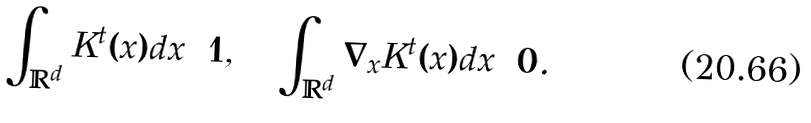Convert formula to latex. <formula><loc_0><loc_0><loc_500><loc_500>\int _ { \mathbb { R } ^ { d } } K ^ { t } ( x ) d x = 1 , \quad \int _ { \mathbb { R } ^ { d } } \nabla _ { x } K ^ { t } ( x ) d x = 0 .</formula> 